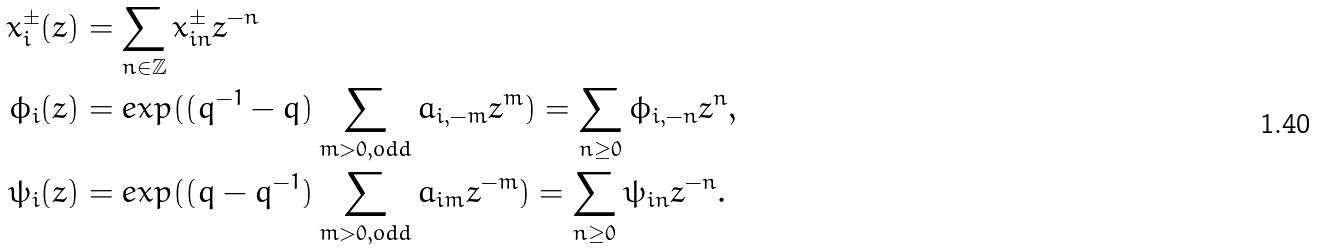Convert formula to latex. <formula><loc_0><loc_0><loc_500><loc_500>x ^ { \pm } _ { i } ( z ) & = \sum _ { n \in \mathbb { Z } } x ^ { \pm } _ { i n } z ^ { - n } \\ \phi _ { i } ( z ) & = e x p ( ( q ^ { - 1 } - q ) \sum _ { m > 0 , o d d } a _ { i , - m } z ^ { m } ) = \sum _ { n \geq 0 } \phi _ { i , - n } z ^ { n } , \\ \psi _ { i } ( z ) & = e x p ( ( q - q ^ { - 1 } ) \sum _ { m > 0 , o d d } a _ { i m } z ^ { - m } ) = \sum _ { n \geq 0 } \psi _ { i n } z ^ { - n } .</formula> 